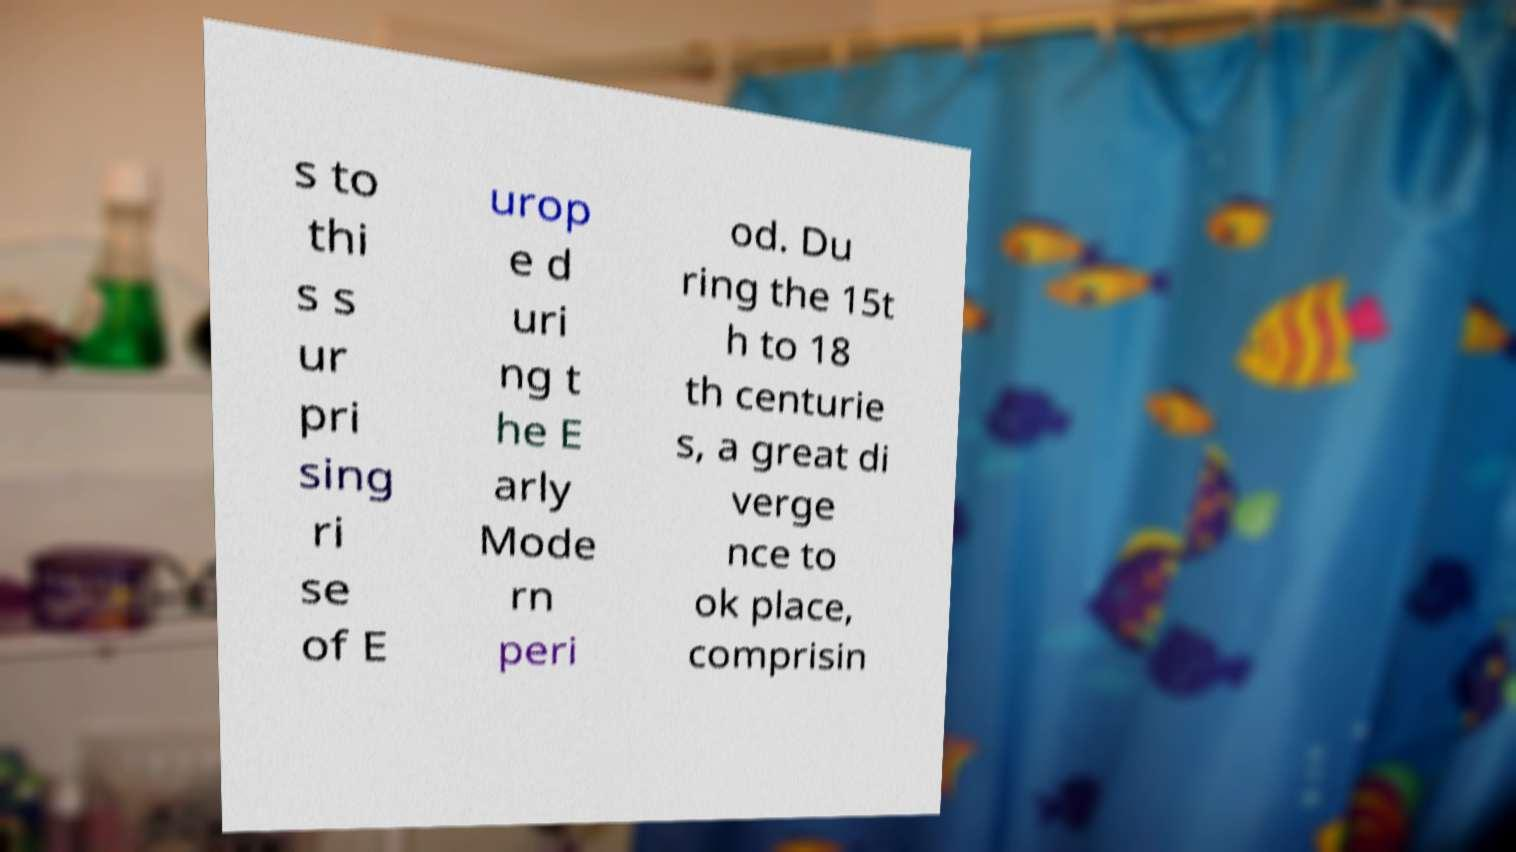What messages or text are displayed in this image? I need them in a readable, typed format. s to thi s s ur pri sing ri se of E urop e d uri ng t he E arly Mode rn peri od. Du ring the 15t h to 18 th centurie s, a great di verge nce to ok place, comprisin 